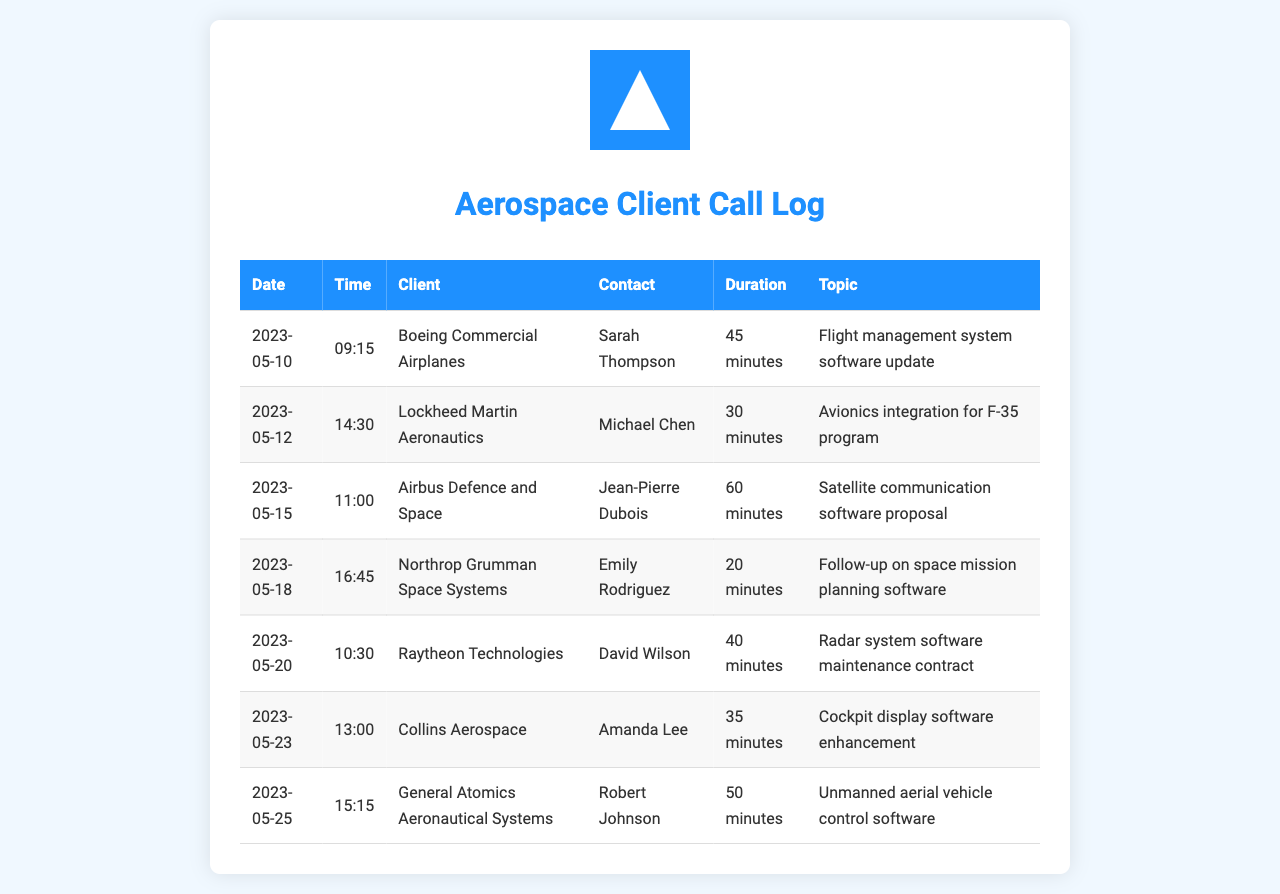What is the duration of the call with Boeing Commercial Airplanes? The duration of the call on May 10, 2023, with Boeing Commercial Airplanes is specified in the document as 45 minutes.
Answer: 45 minutes Who was the contact person for Lockheed Martin Aeronautics? The document lists Michael Chen as the contact person for Lockheed Martin Aeronautics during the call on May 12, 2023.
Answer: Michael Chen How many calls were made in total according to the call log? The document contains a total of 7 entries, indicating 7 calls made.
Answer: 7 What topic was discussed during the call with Airbus Defence and Space? The topic discussed during the call on May 15, 2023, with Airbus Defence and Space was about a satellite communication software proposal.
Answer: Satellite communication software proposal Which company had the longest call duration? The longest call duration in the document is with Airbus Defence and Space, lasting for 60 minutes.
Answer: Airbus Defence and Space When was the call with General Atomics Aeronautical Systems made? The document states that the call with General Atomics Aeronautical Systems was made on May 25, 2023.
Answer: May 25, 2023 What was the main focus of the call with Collins Aerospace? The main focus of the call with Collins Aerospace on May 23, 2023, was cockpit display software enhancement.
Answer: Cockpit display software enhancement 